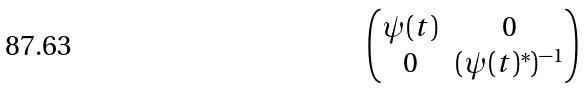<formula> <loc_0><loc_0><loc_500><loc_500>\begin{pmatrix} \psi ( t ) & 0 \\ 0 & ( \psi ( t ) ^ { * } ) ^ { - 1 } \end{pmatrix}</formula> 